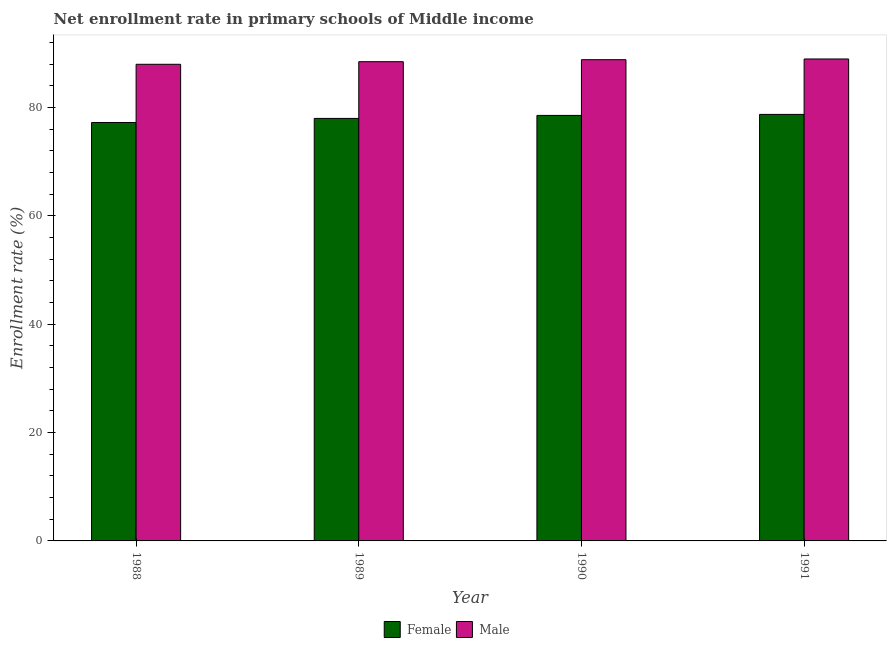How many different coloured bars are there?
Your answer should be very brief. 2. How many groups of bars are there?
Give a very brief answer. 4. Are the number of bars on each tick of the X-axis equal?
Your answer should be very brief. Yes. How many bars are there on the 4th tick from the left?
Offer a terse response. 2. How many bars are there on the 4th tick from the right?
Your answer should be very brief. 2. In how many cases, is the number of bars for a given year not equal to the number of legend labels?
Keep it short and to the point. 0. What is the enrollment rate of female students in 1988?
Make the answer very short. 77.23. Across all years, what is the maximum enrollment rate of male students?
Ensure brevity in your answer.  88.96. Across all years, what is the minimum enrollment rate of female students?
Your answer should be compact. 77.23. What is the total enrollment rate of female students in the graph?
Provide a short and direct response. 312.49. What is the difference between the enrollment rate of male students in 1988 and that in 1991?
Offer a very short reply. -0.98. What is the difference between the enrollment rate of female students in 1989 and the enrollment rate of male students in 1991?
Offer a very short reply. -0.74. What is the average enrollment rate of female students per year?
Offer a terse response. 78.12. What is the ratio of the enrollment rate of male students in 1989 to that in 1991?
Offer a very short reply. 0.99. Is the enrollment rate of female students in 1989 less than that in 1991?
Ensure brevity in your answer.  Yes. Is the difference between the enrollment rate of female students in 1988 and 1990 greater than the difference between the enrollment rate of male students in 1988 and 1990?
Offer a very short reply. No. What is the difference between the highest and the second highest enrollment rate of male students?
Ensure brevity in your answer.  0.13. What is the difference between the highest and the lowest enrollment rate of male students?
Your response must be concise. 0.98. In how many years, is the enrollment rate of female students greater than the average enrollment rate of female students taken over all years?
Offer a terse response. 2. Are all the bars in the graph horizontal?
Your answer should be compact. No. How many years are there in the graph?
Offer a terse response. 4. What is the difference between two consecutive major ticks on the Y-axis?
Offer a very short reply. 20. Are the values on the major ticks of Y-axis written in scientific E-notation?
Your answer should be compact. No. Where does the legend appear in the graph?
Provide a short and direct response. Bottom center. How are the legend labels stacked?
Offer a terse response. Horizontal. What is the title of the graph?
Your response must be concise. Net enrollment rate in primary schools of Middle income. What is the label or title of the X-axis?
Keep it short and to the point. Year. What is the label or title of the Y-axis?
Offer a very short reply. Enrollment rate (%). What is the Enrollment rate (%) in Female in 1988?
Offer a terse response. 77.23. What is the Enrollment rate (%) in Male in 1988?
Keep it short and to the point. 87.98. What is the Enrollment rate (%) of Female in 1989?
Your answer should be compact. 77.99. What is the Enrollment rate (%) of Male in 1989?
Your answer should be very brief. 88.46. What is the Enrollment rate (%) of Female in 1990?
Offer a terse response. 78.54. What is the Enrollment rate (%) in Male in 1990?
Give a very brief answer. 88.83. What is the Enrollment rate (%) of Female in 1991?
Offer a terse response. 78.73. What is the Enrollment rate (%) of Male in 1991?
Your answer should be very brief. 88.96. Across all years, what is the maximum Enrollment rate (%) in Female?
Ensure brevity in your answer.  78.73. Across all years, what is the maximum Enrollment rate (%) in Male?
Give a very brief answer. 88.96. Across all years, what is the minimum Enrollment rate (%) of Female?
Your answer should be compact. 77.23. Across all years, what is the minimum Enrollment rate (%) in Male?
Provide a short and direct response. 87.98. What is the total Enrollment rate (%) in Female in the graph?
Your answer should be very brief. 312.49. What is the total Enrollment rate (%) in Male in the graph?
Ensure brevity in your answer.  354.22. What is the difference between the Enrollment rate (%) in Female in 1988 and that in 1989?
Your answer should be very brief. -0.75. What is the difference between the Enrollment rate (%) in Male in 1988 and that in 1989?
Your response must be concise. -0.48. What is the difference between the Enrollment rate (%) in Female in 1988 and that in 1990?
Your answer should be compact. -1.31. What is the difference between the Enrollment rate (%) of Male in 1988 and that in 1990?
Your answer should be very brief. -0.85. What is the difference between the Enrollment rate (%) in Female in 1988 and that in 1991?
Give a very brief answer. -1.49. What is the difference between the Enrollment rate (%) in Male in 1988 and that in 1991?
Keep it short and to the point. -0.98. What is the difference between the Enrollment rate (%) in Female in 1989 and that in 1990?
Provide a short and direct response. -0.55. What is the difference between the Enrollment rate (%) in Male in 1989 and that in 1990?
Give a very brief answer. -0.37. What is the difference between the Enrollment rate (%) of Female in 1989 and that in 1991?
Make the answer very short. -0.74. What is the difference between the Enrollment rate (%) of Male in 1989 and that in 1991?
Offer a terse response. -0.5. What is the difference between the Enrollment rate (%) of Female in 1990 and that in 1991?
Give a very brief answer. -0.19. What is the difference between the Enrollment rate (%) in Male in 1990 and that in 1991?
Your answer should be compact. -0.13. What is the difference between the Enrollment rate (%) of Female in 1988 and the Enrollment rate (%) of Male in 1989?
Ensure brevity in your answer.  -11.22. What is the difference between the Enrollment rate (%) of Female in 1988 and the Enrollment rate (%) of Male in 1990?
Your response must be concise. -11.59. What is the difference between the Enrollment rate (%) of Female in 1988 and the Enrollment rate (%) of Male in 1991?
Your answer should be compact. -11.72. What is the difference between the Enrollment rate (%) of Female in 1989 and the Enrollment rate (%) of Male in 1990?
Your answer should be very brief. -10.84. What is the difference between the Enrollment rate (%) of Female in 1989 and the Enrollment rate (%) of Male in 1991?
Make the answer very short. -10.97. What is the difference between the Enrollment rate (%) of Female in 1990 and the Enrollment rate (%) of Male in 1991?
Your answer should be very brief. -10.42. What is the average Enrollment rate (%) of Female per year?
Your response must be concise. 78.12. What is the average Enrollment rate (%) of Male per year?
Ensure brevity in your answer.  88.55. In the year 1988, what is the difference between the Enrollment rate (%) in Female and Enrollment rate (%) in Male?
Offer a very short reply. -10.74. In the year 1989, what is the difference between the Enrollment rate (%) of Female and Enrollment rate (%) of Male?
Give a very brief answer. -10.47. In the year 1990, what is the difference between the Enrollment rate (%) of Female and Enrollment rate (%) of Male?
Ensure brevity in your answer.  -10.28. In the year 1991, what is the difference between the Enrollment rate (%) of Female and Enrollment rate (%) of Male?
Make the answer very short. -10.23. What is the ratio of the Enrollment rate (%) in Female in 1988 to that in 1990?
Ensure brevity in your answer.  0.98. What is the ratio of the Enrollment rate (%) of Female in 1988 to that in 1991?
Give a very brief answer. 0.98. What is the ratio of the Enrollment rate (%) in Female in 1989 to that in 1990?
Ensure brevity in your answer.  0.99. What is the ratio of the Enrollment rate (%) of Female in 1989 to that in 1991?
Offer a very short reply. 0.99. What is the ratio of the Enrollment rate (%) of Male in 1989 to that in 1991?
Provide a short and direct response. 0.99. What is the ratio of the Enrollment rate (%) of Male in 1990 to that in 1991?
Make the answer very short. 1. What is the difference between the highest and the second highest Enrollment rate (%) in Female?
Your response must be concise. 0.19. What is the difference between the highest and the second highest Enrollment rate (%) in Male?
Keep it short and to the point. 0.13. What is the difference between the highest and the lowest Enrollment rate (%) of Female?
Keep it short and to the point. 1.49. What is the difference between the highest and the lowest Enrollment rate (%) of Male?
Make the answer very short. 0.98. 